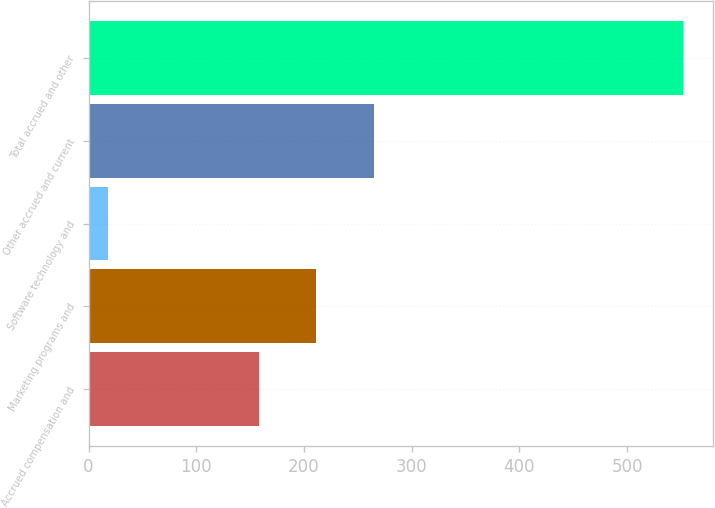Convert chart. <chart><loc_0><loc_0><loc_500><loc_500><bar_chart><fcel>Accrued compensation and<fcel>Marketing programs and<fcel>Software technology and<fcel>Other accrued and current<fcel>Total accrued and other<nl><fcel>158<fcel>211.4<fcel>18<fcel>264.8<fcel>552<nl></chart> 